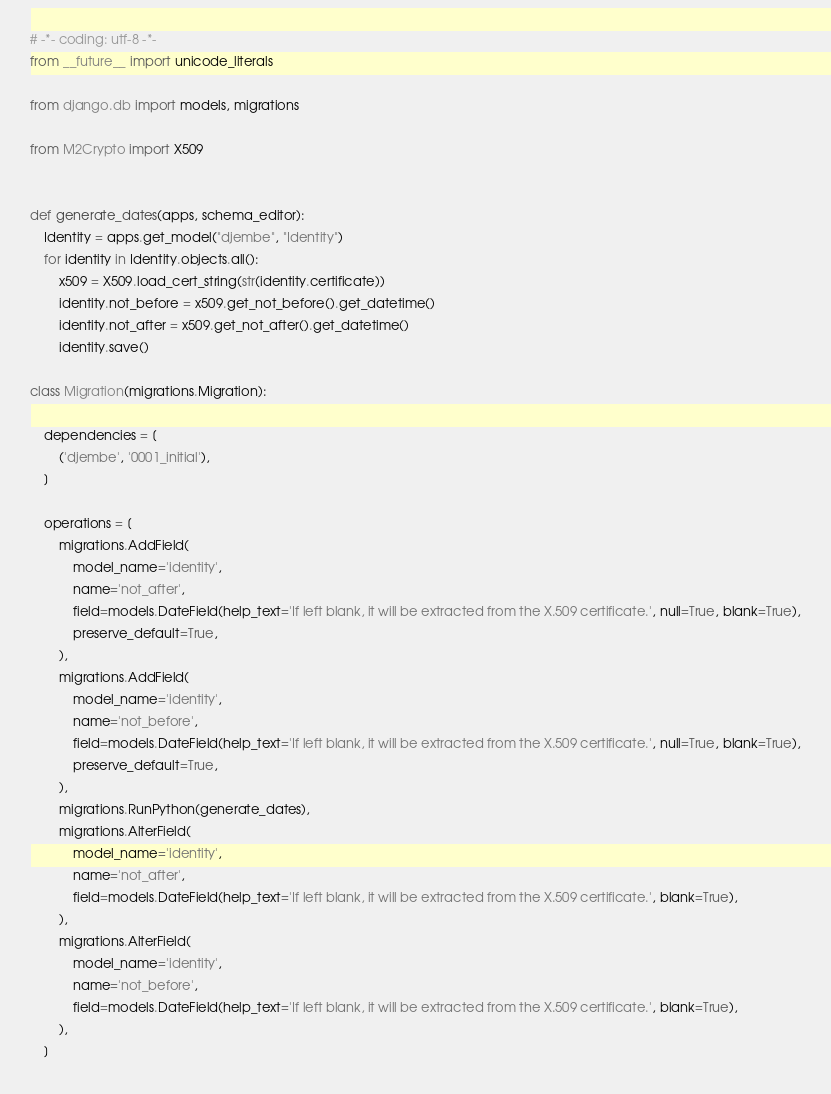Convert code to text. <code><loc_0><loc_0><loc_500><loc_500><_Python_># -*- coding: utf-8 -*-
from __future__ import unicode_literals

from django.db import models, migrations

from M2Crypto import X509


def generate_dates(apps, schema_editor):
    Identity = apps.get_model("djembe", "Identity")
    for identity in Identity.objects.all():
        x509 = X509.load_cert_string(str(identity.certificate))
        identity.not_before = x509.get_not_before().get_datetime()
        identity.not_after = x509.get_not_after().get_datetime()
        identity.save()

class Migration(migrations.Migration):

    dependencies = [
        ('djembe', '0001_initial'),
    ]

    operations = [
        migrations.AddField(
            model_name='identity',
            name='not_after',
            field=models.DateField(help_text='If left blank, it will be extracted from the X.509 certificate.', null=True, blank=True),
            preserve_default=True,
        ),
        migrations.AddField(
            model_name='identity',
            name='not_before',
            field=models.DateField(help_text='If left blank, it will be extracted from the X.509 certificate.', null=True, blank=True),
            preserve_default=True,
        ),
        migrations.RunPython(generate_dates),
        migrations.AlterField(
            model_name='identity',
            name='not_after',
            field=models.DateField(help_text='If left blank, it will be extracted from the X.509 certificate.', blank=True),
        ),
        migrations.AlterField(
            model_name='identity',
            name='not_before',
            field=models.DateField(help_text='If left blank, it will be extracted from the X.509 certificate.', blank=True),
        ),
    ]
</code> 